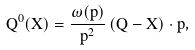Convert formula to latex. <formula><loc_0><loc_0><loc_500><loc_500>Q ^ { 0 } ( \vec { X } ) = \frac { \omega ( p ) } { \vec { p } ^ { 2 } } \, ( \vec { Q } - \vec { X } ) \cdot \vec { p } ,</formula> 